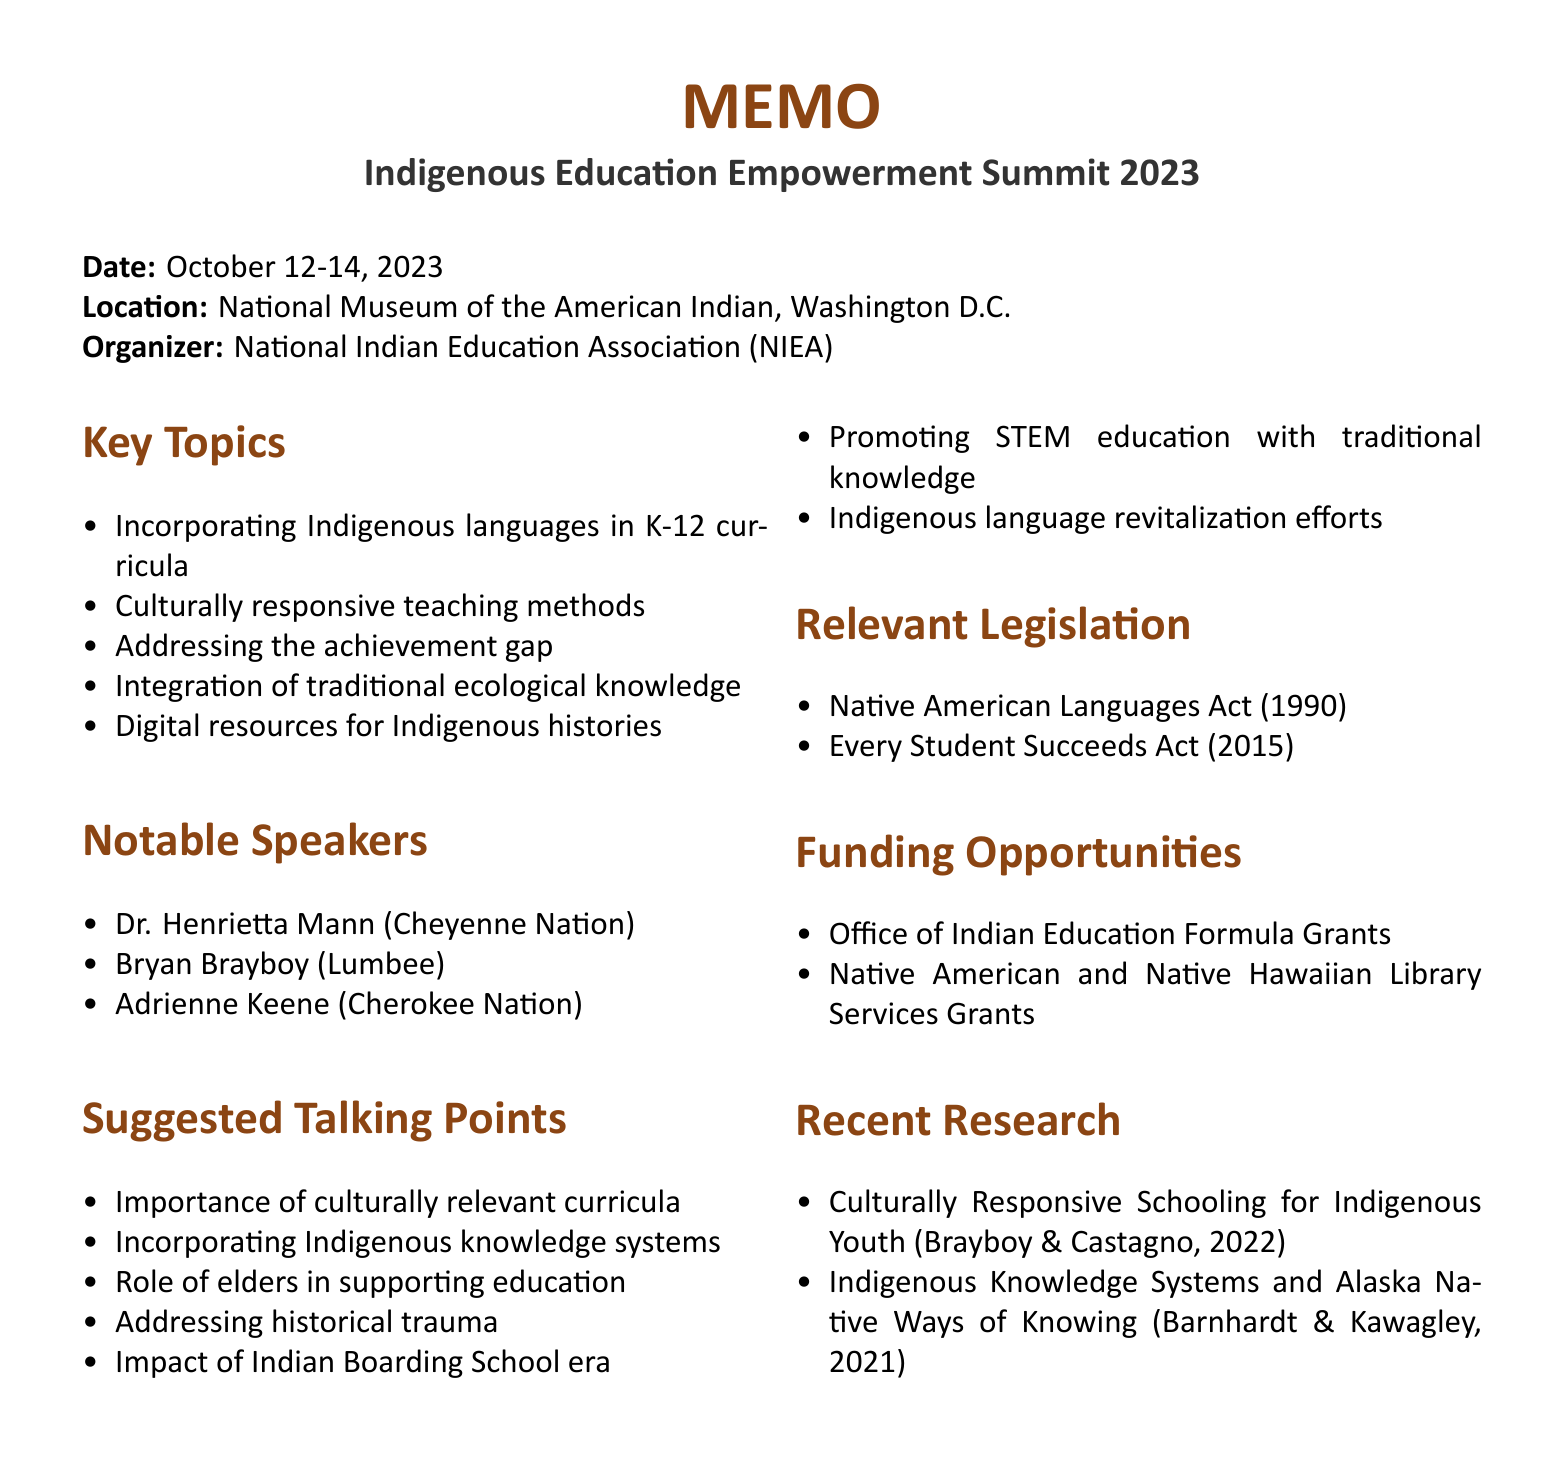What is the name of the conference? The name of the conference can be found at the top of the document detailing the event in question.
Answer: Indigenous Education Empowerment Summit 2023 When is the conference taking place? The date is explicitly mentioned in the conference details section of the memo.
Answer: October 12-14, 2023 Where is the conference located? The location is specified directly following the date in the conference details.
Answer: National Museum of the American Indian, Washington D.C Who is the organizer of the conference? The organizer's name is stated directly in the conference details section.
Answer: National Indian Education Association (NIEA) What is one key topic discussed at the conference? Key topics are listed in the document under their respective section.
Answer: Incorporating Indigenous languages in K-12 curricula Name one notable speaker at the conference. The notable speakers are listed, and I can identify one from that section.
Answer: Dr. Henrietta Mann What is the focus of the Office of Indian Education Formula Grants? The focus of this funding opportunity is detailed in the funding opportunities section of the memo.
Answer: Supporting the efforts of local educational agencies to meet the unique cultural, language, and educational needs of Indian students What legislation recognizes the right of Native Americans to use their languages in education? This information is found under the relevant legislation section of the memo.
Answer: Native American Languages Act of 1990 How many key topics are listed in the memo? The number of key topics can be counted from the key topics section of the memo.
Answer: Five 